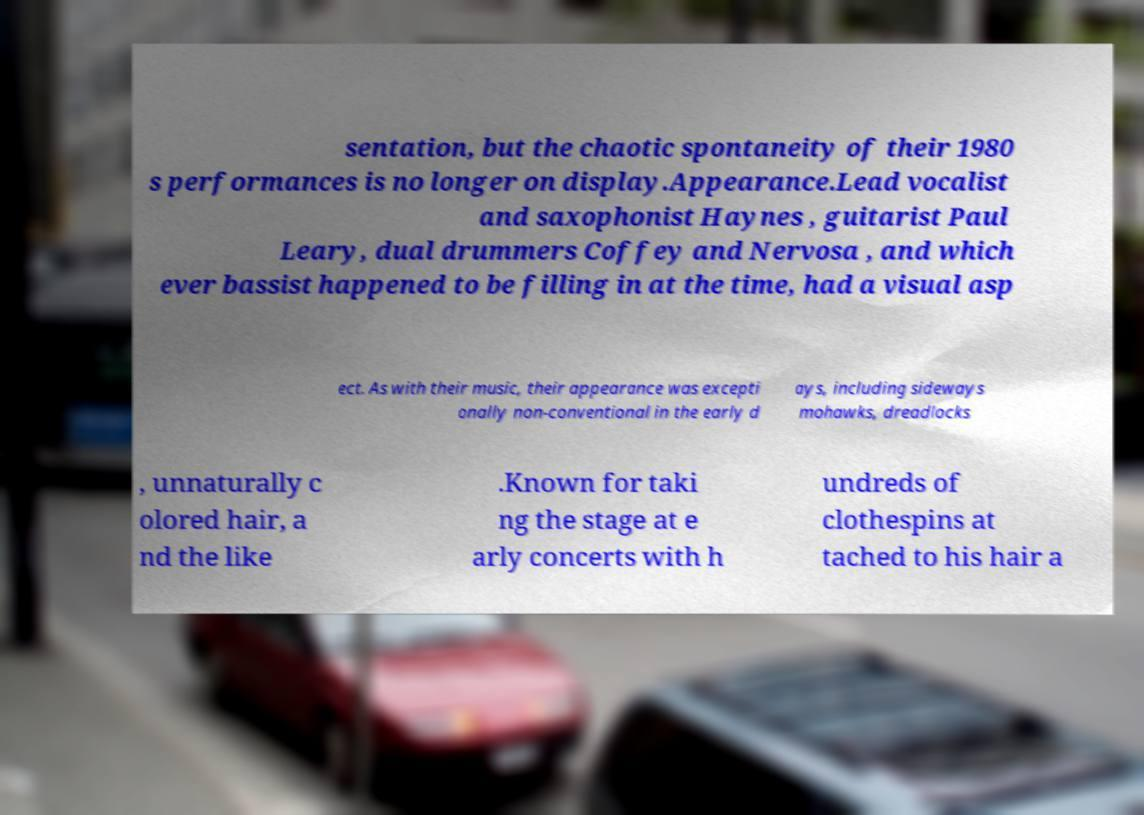What messages or text are displayed in this image? I need them in a readable, typed format. sentation, but the chaotic spontaneity of their 1980 s performances is no longer on display.Appearance.Lead vocalist and saxophonist Haynes , guitarist Paul Leary, dual drummers Coffey and Nervosa , and which ever bassist happened to be filling in at the time, had a visual asp ect. As with their music, their appearance was excepti onally non-conventional in the early d ays, including sideways mohawks, dreadlocks , unnaturally c olored hair, a nd the like .Known for taki ng the stage at e arly concerts with h undreds of clothespins at tached to his hair a 